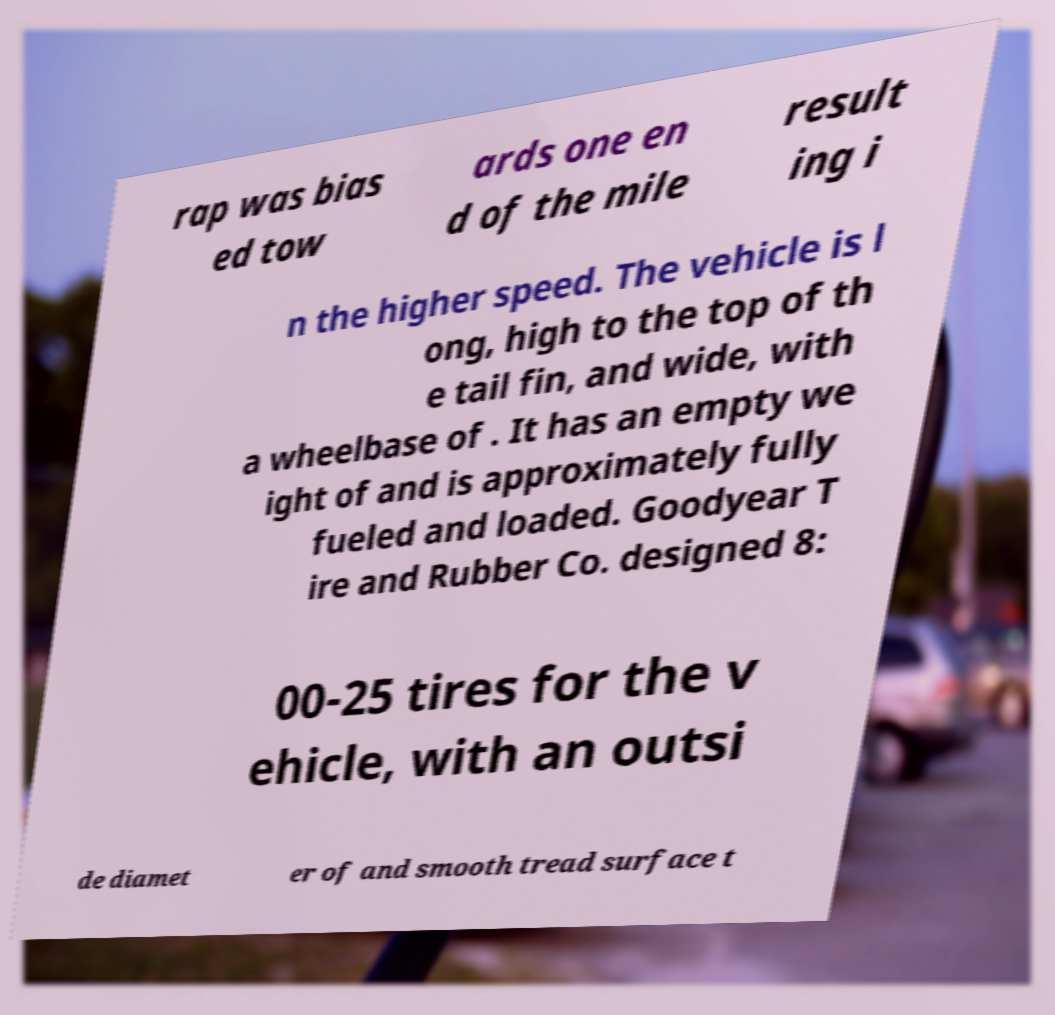Please read and relay the text visible in this image. What does it say? rap was bias ed tow ards one en d of the mile result ing i n the higher speed. The vehicle is l ong, high to the top of th e tail fin, and wide, with a wheelbase of . It has an empty we ight of and is approximately fully fueled and loaded. Goodyear T ire and Rubber Co. designed 8: 00-25 tires for the v ehicle, with an outsi de diamet er of and smooth tread surface t 